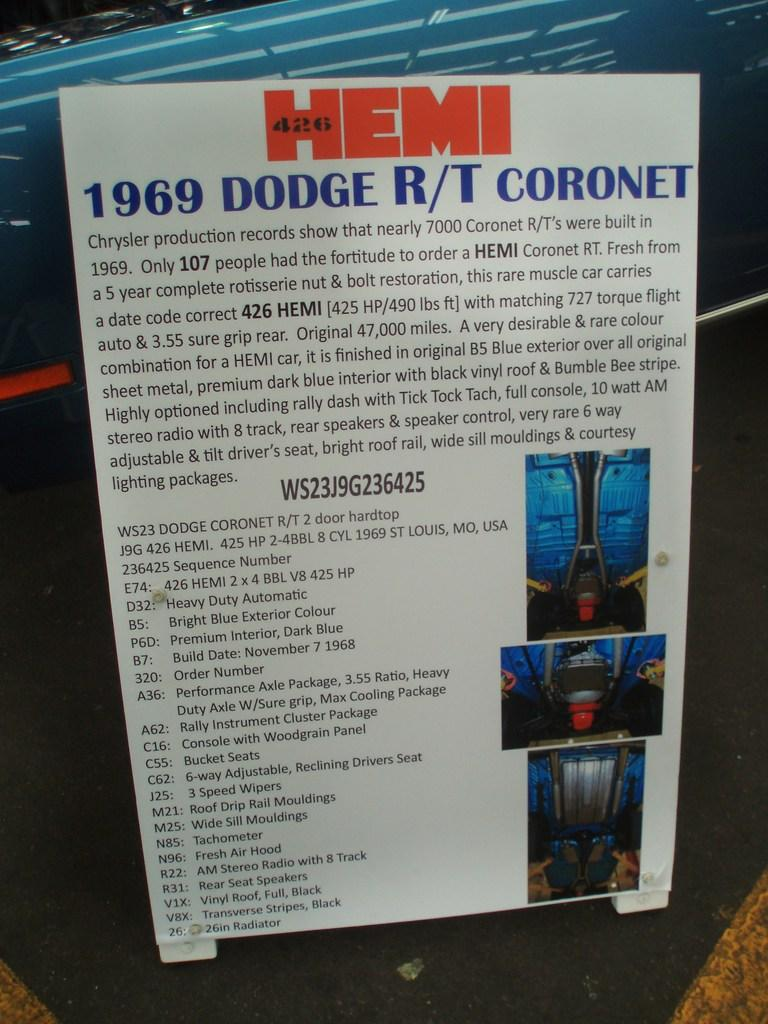<image>
Share a concise interpretation of the image provided. A sign that says HEMI at the top has the year 1969 on it. 